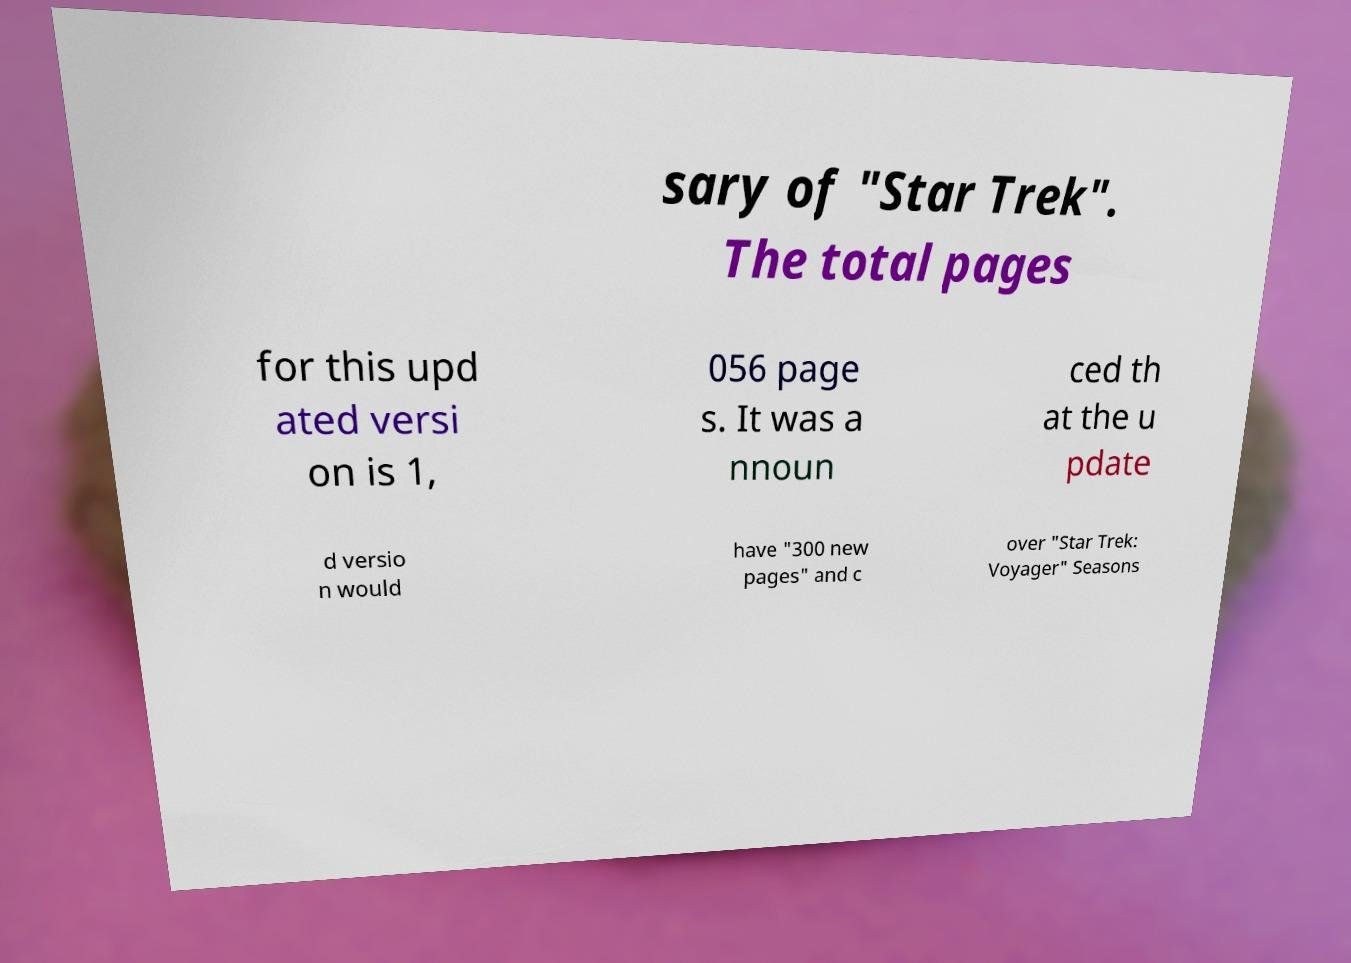Could you assist in decoding the text presented in this image and type it out clearly? sary of "Star Trek". The total pages for this upd ated versi on is 1, 056 page s. It was a nnoun ced th at the u pdate d versio n would have "300 new pages" and c over "Star Trek: Voyager" Seasons 